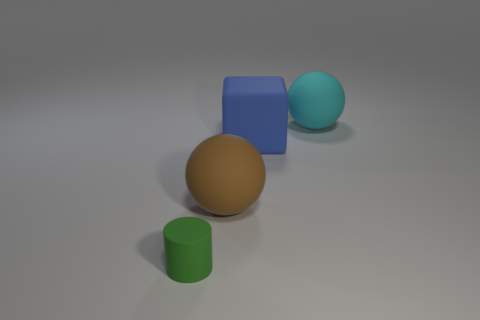Add 2 cylinders. How many objects exist? 6 Subtract all cylinders. How many objects are left? 3 Subtract all large things. Subtract all big cubes. How many objects are left? 0 Add 3 big brown matte objects. How many big brown matte objects are left? 4 Add 4 blue metal balls. How many blue metal balls exist? 4 Subtract 0 blue cylinders. How many objects are left? 4 